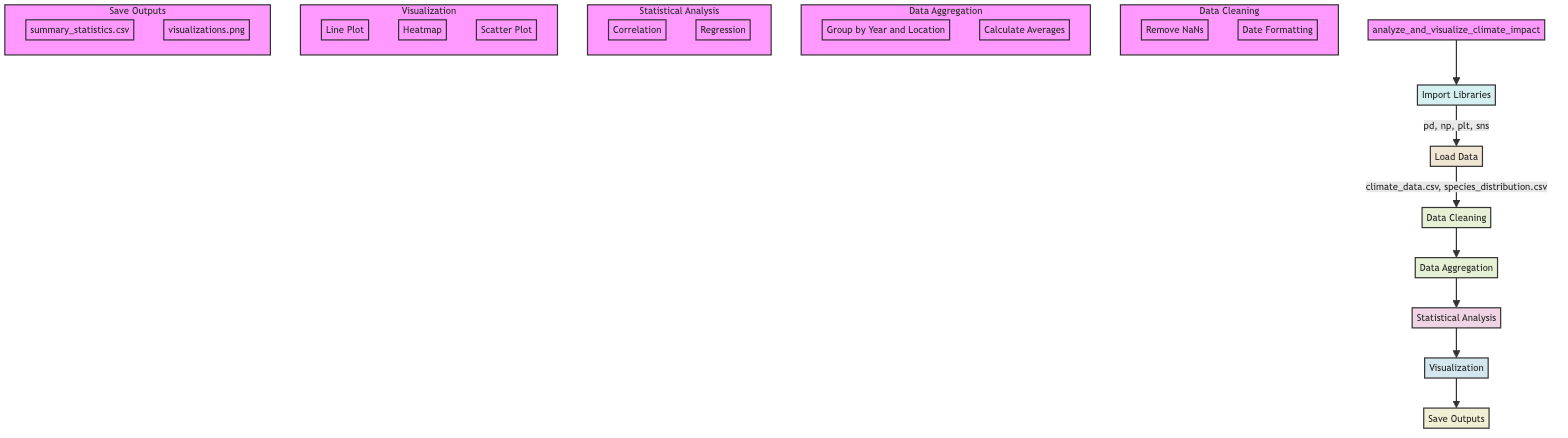What operations are performed in the "Data Cleaning" step? The "Data Cleaning" step contains two operations: "Remove NaNs" and "Date Formatting." These actions are shown in the subgraph under the main flowchart, indicating that these are essential tasks before proceeding to the next steps in the analysis.
Answer: Remove NaNs, Date Formatting How many datasets are loaded in the "Load Data" step? In the "Load Data" step, two datasets are mentioned: "climate_data.csv" and "species_distribution.csv." This is determined by observing the content of this node, which lists the datasets that are being loaded for analysis.
Answer: 2 Which library is imported with the alias "sns"? The library imported with the alias "sns" is "seaborn." This can be confirmed by looking at the "Import Libraries" step, where the specific libraries and their aliases are defined.
Answer: seaborn What type of plot is used to visualize trends in temperature and species counts over time? The type of plot used to visualize trends in temperature and species counts over time is a "Line Plot." This information is included in the "Visualization" step of the diagram, detailing the specific plots generated for analysis.
Answer: Line Plot What is the final output saved as in the "Save Outputs" step? The final output saved in the "Save Outputs" step is "visualizations.png," which indicates that the generated plots will be saved as an image file. This is evident from the content of the output node detailing file types and names.
Answer: visualizations.png What statistical analysis is performed after data aggregation? After data aggregation, the statistical analyses performed are "Correlation" and "Regression." This information can be traced through the flow of the diagram, following the sequence from data aggregation to statistical analysis where these two actions are specified.
Answer: Correlation, Regression What relationship does the diagram show between "Data Aggregation" and "Statistical Analysis"? The relationship shows a sequential flow where "Data Aggregation" is a prerequisite that feeds into "Statistical Analysis." Specifically, it illustrates that the aggregated data is then subjected to various statistical analyses to interpret the climate impact on species.
Answer: Sequential flow What file type is "summary_statistics.csv"? The file type for "summary_statistics.csv" is "CSV." This is specified in the "Save Outputs" section of the diagram, indicating the format in which summary statistics will be saved.
Answer: CSV 